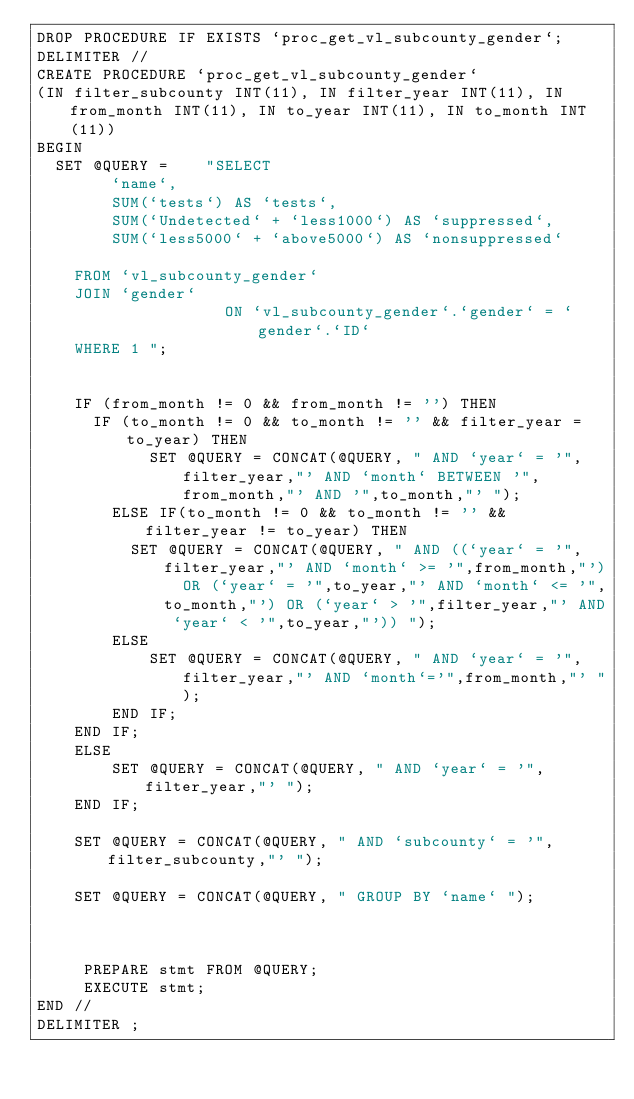<code> <loc_0><loc_0><loc_500><loc_500><_SQL_>DROP PROCEDURE IF EXISTS `proc_get_vl_subcounty_gender`;
DELIMITER //
CREATE PROCEDURE `proc_get_vl_subcounty_gender`
(IN filter_subcounty INT(11), IN filter_year INT(11), IN from_month INT(11), IN to_year INT(11), IN to_month INT(11))
BEGIN
  SET @QUERY =    "SELECT
        `name`,
        SUM(`tests`) AS `tests`, 
        SUM(`Undetected` + `less1000`) AS `suppressed`, 
        SUM(`less5000` + `above5000`) AS `nonsuppressed`

    FROM `vl_subcounty_gender`
    JOIN `gender` 
                    ON `vl_subcounty_gender`.`gender` = `gender`.`ID`
    WHERE 1 ";


    IF (from_month != 0 && from_month != '') THEN
      IF (to_month != 0 && to_month != '' && filter_year = to_year) THEN
            SET @QUERY = CONCAT(@QUERY, " AND `year` = '",filter_year,"' AND `month` BETWEEN '",from_month,"' AND '",to_month,"' ");
        ELSE IF(to_month != 0 && to_month != '' && filter_year != to_year) THEN
          SET @QUERY = CONCAT(@QUERY, " AND ((`year` = '",filter_year,"' AND `month` >= '",from_month,"')  OR (`year` = '",to_year,"' AND `month` <= '",to_month,"') OR (`year` > '",filter_year,"' AND `year` < '",to_year,"')) ");
        ELSE
            SET @QUERY = CONCAT(@QUERY, " AND `year` = '",filter_year,"' AND `month`='",from_month,"' ");
        END IF;
    END IF;
    ELSE
        SET @QUERY = CONCAT(@QUERY, " AND `year` = '",filter_year,"' ");
    END IF;

    SET @QUERY = CONCAT(@QUERY, " AND `subcounty` = '",filter_subcounty,"' ");

    SET @QUERY = CONCAT(@QUERY, " GROUP BY `name` ");



     PREPARE stmt FROM @QUERY;
     EXECUTE stmt;
END //
DELIMITER ;
</code> 